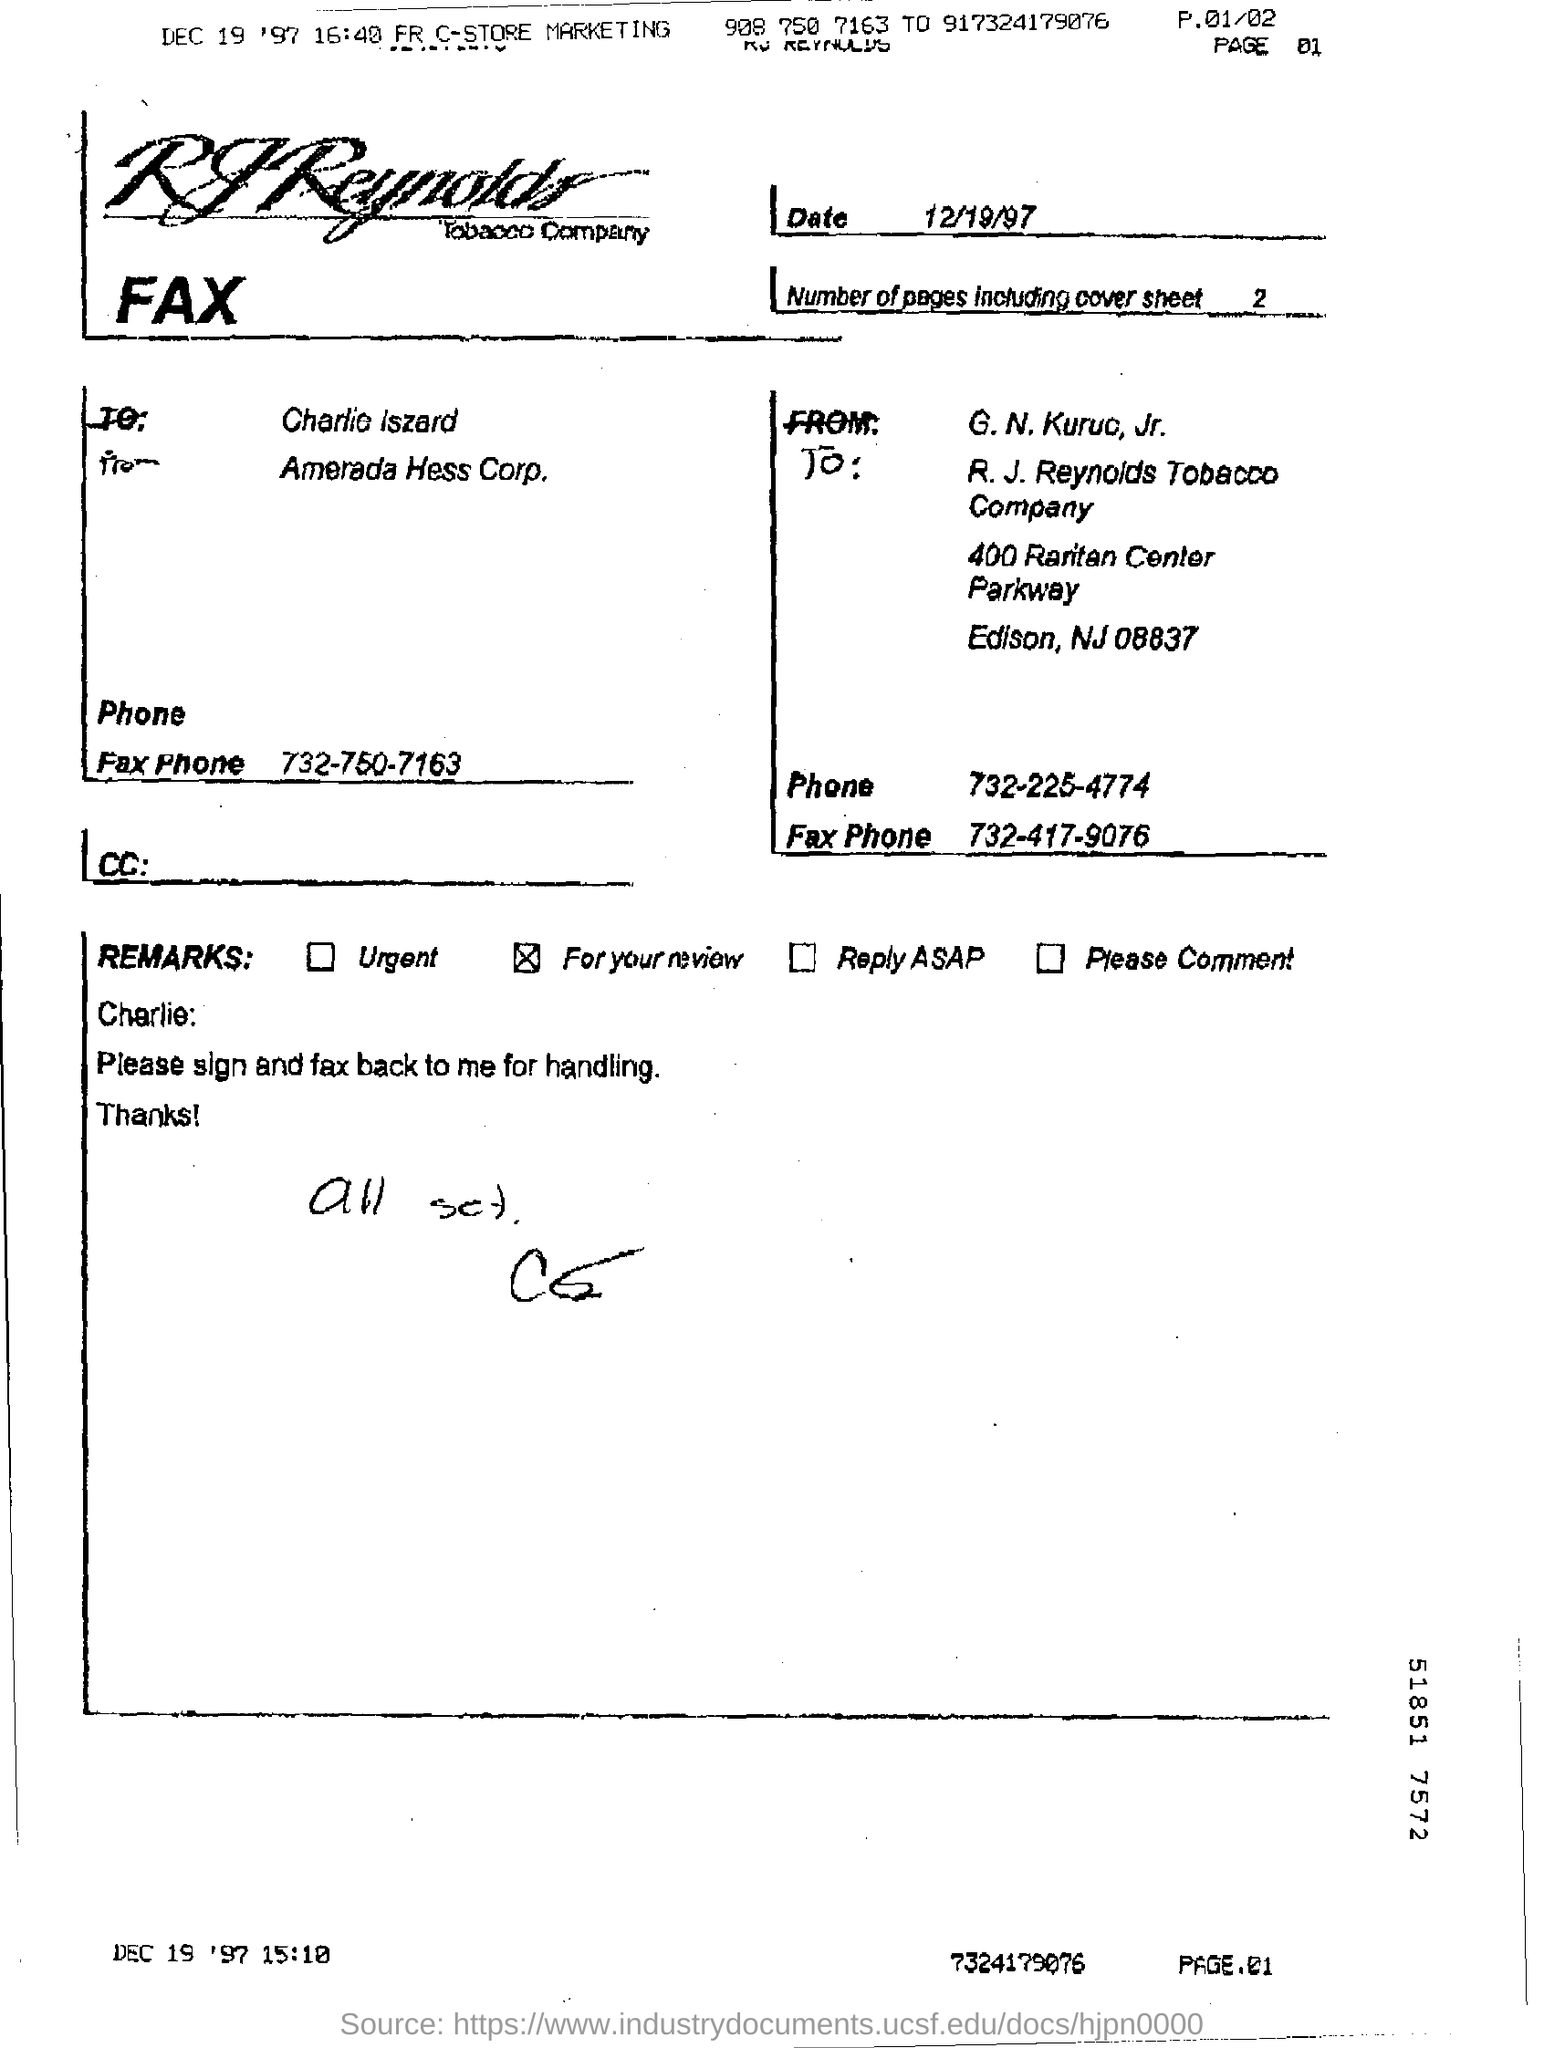What is the date on the Fax?
Your answer should be very brief. 12/19/97. 